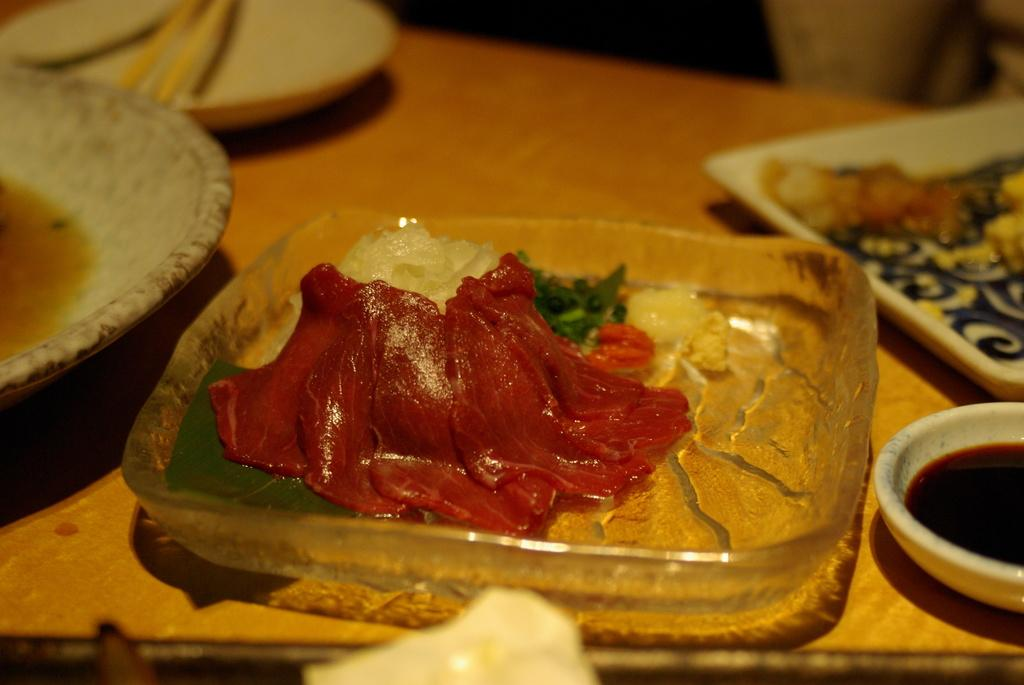What is in the bowls that are visible in the image? There are bowls containing food in the image. What is used to carry or hold the food in the image? There is a tray in the image. What type of condiment is in a separate bowl in the image? There is a bowl containing sauce in the image. What utensils are present on the table in the image? There are chopsticks in a plate on the table in the image. What is the name of the rod that is holding up the bowls in the image? There is no rod holding up the bowls in the image; they are resting on a surface. 